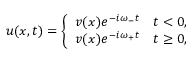<formula> <loc_0><loc_0><loc_500><loc_500>\begin{array} { r } { u ( x , t ) = \left \{ \begin{array} { l l } { v ( x ) e ^ { - i \omega _ { - } t } } & { t < 0 , } \\ { v ( x ) e ^ { - i \omega _ { + } t } } & { t \geq 0 , } \end{array} } \end{array}</formula> 